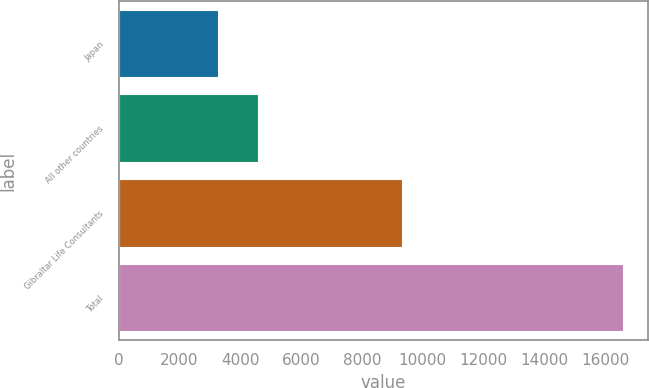Convert chart. <chart><loc_0><loc_0><loc_500><loc_500><bar_chart><fcel>Japan<fcel>All other countries<fcel>Gibraltar Life Consultants<fcel>Total<nl><fcel>3258<fcel>4589.7<fcel>9327<fcel>16575<nl></chart> 